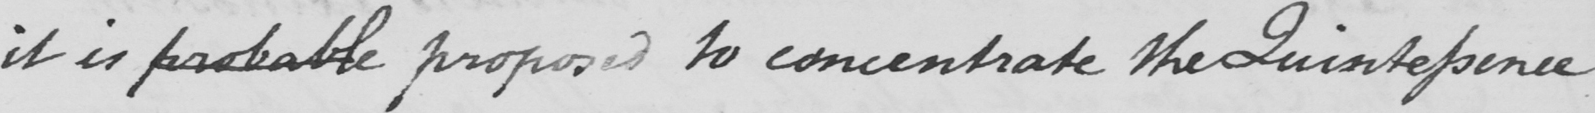Please transcribe the handwritten text in this image. it is probable proposed to concentrate the Quintessence 